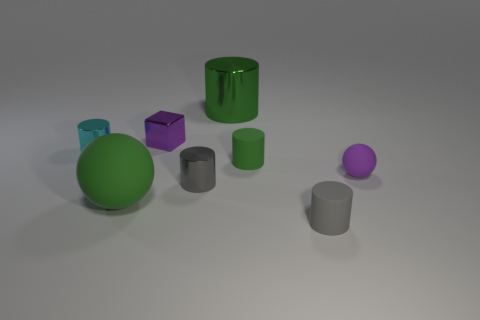Is there any other thing that has the same material as the purple cube?
Your response must be concise. Yes. What number of big objects are either green metallic things or purple rubber balls?
Offer a very short reply. 1. There is a tiny thing that is the same color as the big ball; what shape is it?
Your answer should be very brief. Cylinder. Is the small gray cylinder that is behind the gray rubber thing made of the same material as the purple ball?
Give a very brief answer. No. The gray cylinder that is behind the matte sphere that is on the left side of the small purple rubber object is made of what material?
Your answer should be very brief. Metal. What number of small purple things are the same shape as the cyan thing?
Give a very brief answer. 0. How big is the green thing that is in front of the gray object behind the matte sphere in front of the tiny purple matte ball?
Your response must be concise. Large. How many green things are small things or small matte cylinders?
Offer a terse response. 1. There is a metallic thing that is in front of the cyan shiny cylinder; is its shape the same as the purple metal thing?
Offer a very short reply. No. Is the number of large metal cylinders that are in front of the tiny purple cube greater than the number of green metallic objects?
Your response must be concise. No. 